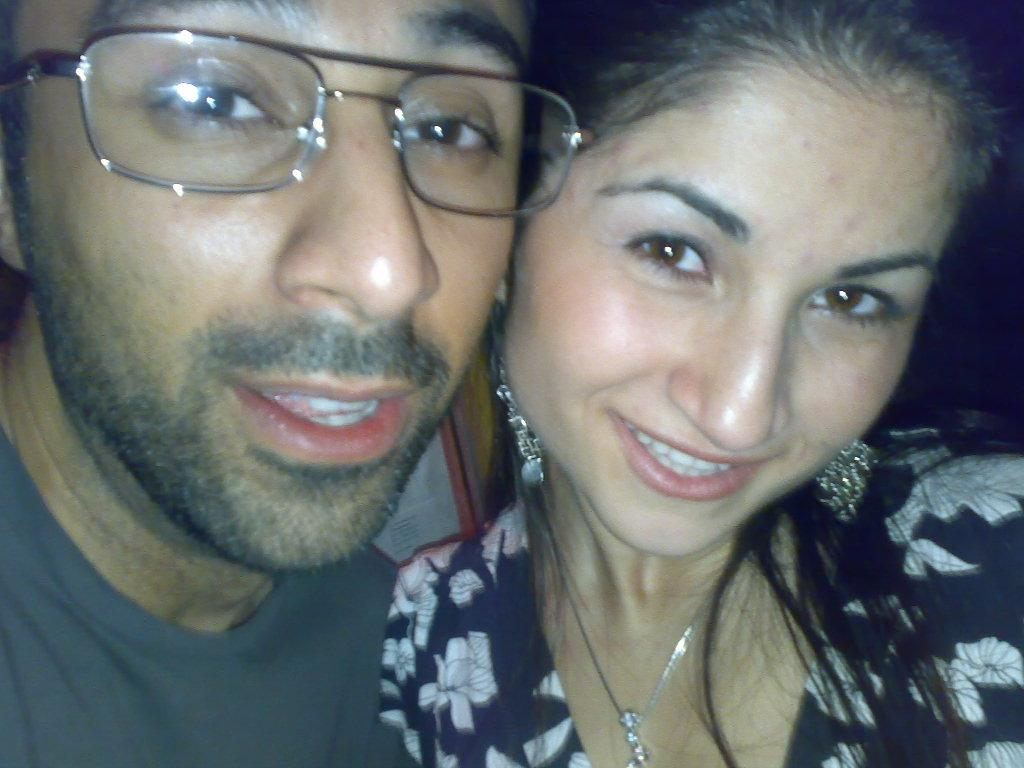Who is present in the image? There is a man and a woman in the image. What is the man wearing in the image? The man is wearing a grey t-shirt in the image. What accessory is the man wearing in the image? The man is wearing spectacles in the image. What is the woman wearing in the image? The woman is wearing a black and white dress in the image. What type of chess game is the man playing with his daughter in the image? There is no chess game or daughter present in the image. 